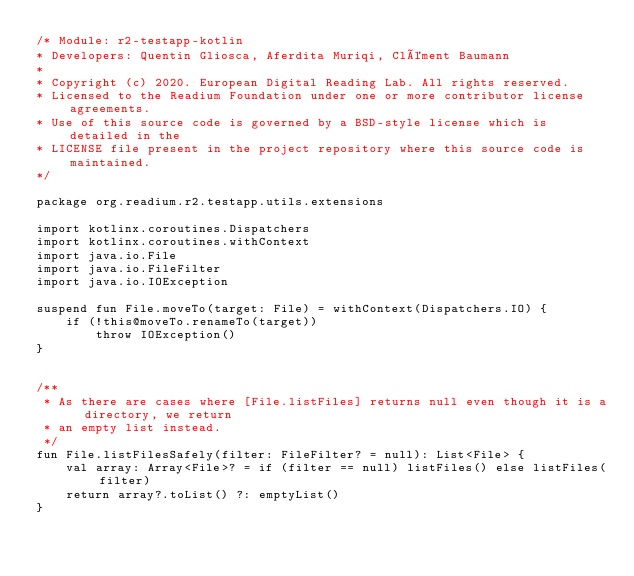Convert code to text. <code><loc_0><loc_0><loc_500><loc_500><_Kotlin_>/* Module: r2-testapp-kotlin
* Developers: Quentin Gliosca, Aferdita Muriqi, Clément Baumann
*
* Copyright (c) 2020. European Digital Reading Lab. All rights reserved.
* Licensed to the Readium Foundation under one or more contributor license agreements.
* Use of this source code is governed by a BSD-style license which is detailed in the
* LICENSE file present in the project repository where this source code is maintained.
*/

package org.readium.r2.testapp.utils.extensions

import kotlinx.coroutines.Dispatchers
import kotlinx.coroutines.withContext
import java.io.File
import java.io.FileFilter
import java.io.IOException

suspend fun File.moveTo(target: File) = withContext(Dispatchers.IO) {
    if (!this@moveTo.renameTo(target))
        throw IOException()
}


/**
 * As there are cases where [File.listFiles] returns null even though it is a directory, we return
 * an empty list instead.
 */
fun File.listFilesSafely(filter: FileFilter? = null): List<File> {
    val array: Array<File>? = if (filter == null) listFiles() else listFiles(filter)
    return array?.toList() ?: emptyList()
}</code> 